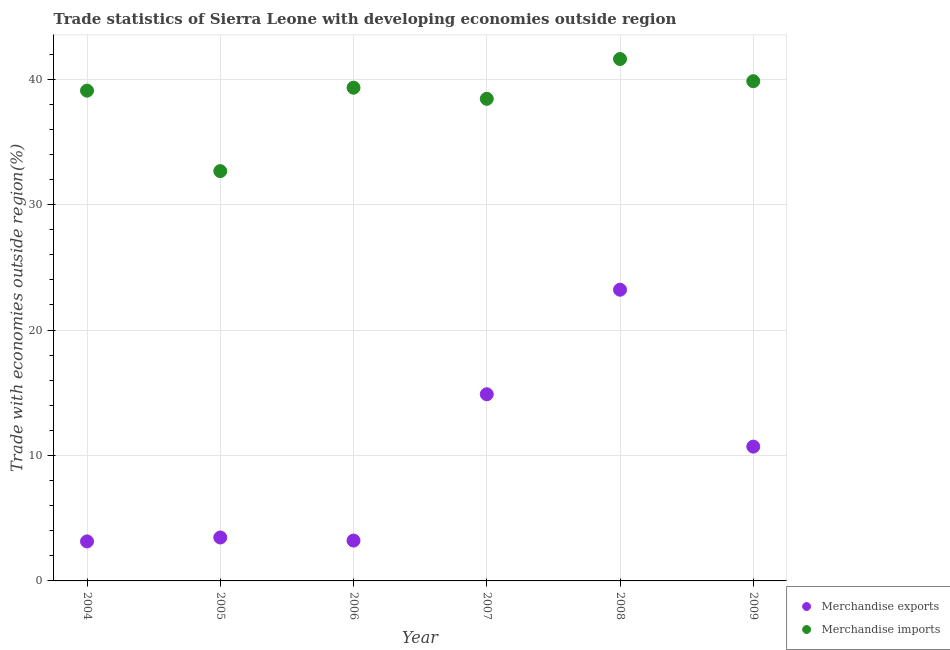Is the number of dotlines equal to the number of legend labels?
Your answer should be very brief. Yes. What is the merchandise imports in 2005?
Provide a short and direct response. 32.67. Across all years, what is the maximum merchandise exports?
Ensure brevity in your answer.  23.22. Across all years, what is the minimum merchandise exports?
Your answer should be very brief. 3.15. In which year was the merchandise exports maximum?
Offer a very short reply. 2008. In which year was the merchandise imports minimum?
Offer a very short reply. 2005. What is the total merchandise imports in the graph?
Your answer should be very brief. 230.96. What is the difference between the merchandise exports in 2005 and that in 2006?
Keep it short and to the point. 0.24. What is the difference between the merchandise imports in 2008 and the merchandise exports in 2009?
Offer a terse response. 30.9. What is the average merchandise exports per year?
Give a very brief answer. 9.77. In the year 2009, what is the difference between the merchandise imports and merchandise exports?
Keep it short and to the point. 29.13. What is the ratio of the merchandise exports in 2005 to that in 2009?
Provide a succinct answer. 0.32. Is the merchandise imports in 2008 less than that in 2009?
Keep it short and to the point. No. Is the difference between the merchandise exports in 2004 and 2005 greater than the difference between the merchandise imports in 2004 and 2005?
Your answer should be very brief. No. What is the difference between the highest and the second highest merchandise exports?
Provide a short and direct response. 8.33. What is the difference between the highest and the lowest merchandise exports?
Ensure brevity in your answer.  20.06. Is the merchandise imports strictly less than the merchandise exports over the years?
Give a very brief answer. No. How many dotlines are there?
Give a very brief answer. 2. Are the values on the major ticks of Y-axis written in scientific E-notation?
Your answer should be very brief. No. Does the graph contain any zero values?
Keep it short and to the point. No. Does the graph contain grids?
Provide a succinct answer. Yes. How many legend labels are there?
Keep it short and to the point. 2. What is the title of the graph?
Ensure brevity in your answer.  Trade statistics of Sierra Leone with developing economies outside region. Does "GDP per capita" appear as one of the legend labels in the graph?
Your response must be concise. No. What is the label or title of the Y-axis?
Ensure brevity in your answer.  Trade with economies outside region(%). What is the Trade with economies outside region(%) in Merchandise exports in 2004?
Make the answer very short. 3.15. What is the Trade with economies outside region(%) in Merchandise imports in 2004?
Offer a very short reply. 39.09. What is the Trade with economies outside region(%) in Merchandise exports in 2005?
Ensure brevity in your answer.  3.46. What is the Trade with economies outside region(%) in Merchandise imports in 2005?
Offer a very short reply. 32.67. What is the Trade with economies outside region(%) in Merchandise exports in 2006?
Give a very brief answer. 3.22. What is the Trade with economies outside region(%) in Merchandise imports in 2006?
Your answer should be very brief. 39.32. What is the Trade with economies outside region(%) of Merchandise exports in 2007?
Offer a very short reply. 14.88. What is the Trade with economies outside region(%) in Merchandise imports in 2007?
Offer a very short reply. 38.44. What is the Trade with economies outside region(%) of Merchandise exports in 2008?
Your answer should be very brief. 23.22. What is the Trade with economies outside region(%) in Merchandise imports in 2008?
Your answer should be very brief. 41.61. What is the Trade with economies outside region(%) of Merchandise exports in 2009?
Keep it short and to the point. 10.71. What is the Trade with economies outside region(%) of Merchandise imports in 2009?
Make the answer very short. 39.84. Across all years, what is the maximum Trade with economies outside region(%) in Merchandise exports?
Offer a terse response. 23.22. Across all years, what is the maximum Trade with economies outside region(%) in Merchandise imports?
Your answer should be very brief. 41.61. Across all years, what is the minimum Trade with economies outside region(%) of Merchandise exports?
Your answer should be very brief. 3.15. Across all years, what is the minimum Trade with economies outside region(%) in Merchandise imports?
Your answer should be very brief. 32.67. What is the total Trade with economies outside region(%) in Merchandise exports in the graph?
Give a very brief answer. 58.63. What is the total Trade with economies outside region(%) of Merchandise imports in the graph?
Ensure brevity in your answer.  230.96. What is the difference between the Trade with economies outside region(%) of Merchandise exports in 2004 and that in 2005?
Provide a succinct answer. -0.31. What is the difference between the Trade with economies outside region(%) in Merchandise imports in 2004 and that in 2005?
Offer a terse response. 6.42. What is the difference between the Trade with economies outside region(%) in Merchandise exports in 2004 and that in 2006?
Offer a terse response. -0.07. What is the difference between the Trade with economies outside region(%) in Merchandise imports in 2004 and that in 2006?
Give a very brief answer. -0.23. What is the difference between the Trade with economies outside region(%) in Merchandise exports in 2004 and that in 2007?
Your answer should be compact. -11.73. What is the difference between the Trade with economies outside region(%) in Merchandise imports in 2004 and that in 2007?
Give a very brief answer. 0.65. What is the difference between the Trade with economies outside region(%) in Merchandise exports in 2004 and that in 2008?
Make the answer very short. -20.06. What is the difference between the Trade with economies outside region(%) of Merchandise imports in 2004 and that in 2008?
Offer a terse response. -2.52. What is the difference between the Trade with economies outside region(%) of Merchandise exports in 2004 and that in 2009?
Make the answer very short. -7.56. What is the difference between the Trade with economies outside region(%) in Merchandise imports in 2004 and that in 2009?
Provide a short and direct response. -0.75. What is the difference between the Trade with economies outside region(%) in Merchandise exports in 2005 and that in 2006?
Ensure brevity in your answer.  0.24. What is the difference between the Trade with economies outside region(%) of Merchandise imports in 2005 and that in 2006?
Your answer should be compact. -6.65. What is the difference between the Trade with economies outside region(%) of Merchandise exports in 2005 and that in 2007?
Offer a terse response. -11.42. What is the difference between the Trade with economies outside region(%) in Merchandise imports in 2005 and that in 2007?
Provide a succinct answer. -5.77. What is the difference between the Trade with economies outside region(%) in Merchandise exports in 2005 and that in 2008?
Make the answer very short. -19.75. What is the difference between the Trade with economies outside region(%) of Merchandise imports in 2005 and that in 2008?
Offer a terse response. -8.94. What is the difference between the Trade with economies outside region(%) in Merchandise exports in 2005 and that in 2009?
Your answer should be very brief. -7.25. What is the difference between the Trade with economies outside region(%) in Merchandise imports in 2005 and that in 2009?
Give a very brief answer. -7.17. What is the difference between the Trade with economies outside region(%) of Merchandise exports in 2006 and that in 2007?
Your answer should be compact. -11.66. What is the difference between the Trade with economies outside region(%) in Merchandise imports in 2006 and that in 2007?
Give a very brief answer. 0.88. What is the difference between the Trade with economies outside region(%) in Merchandise exports in 2006 and that in 2008?
Provide a succinct answer. -20. What is the difference between the Trade with economies outside region(%) of Merchandise imports in 2006 and that in 2008?
Your response must be concise. -2.29. What is the difference between the Trade with economies outside region(%) in Merchandise exports in 2006 and that in 2009?
Your answer should be compact. -7.49. What is the difference between the Trade with economies outside region(%) of Merchandise imports in 2006 and that in 2009?
Offer a very short reply. -0.52. What is the difference between the Trade with economies outside region(%) of Merchandise exports in 2007 and that in 2008?
Keep it short and to the point. -8.33. What is the difference between the Trade with economies outside region(%) of Merchandise imports in 2007 and that in 2008?
Make the answer very short. -3.17. What is the difference between the Trade with economies outside region(%) in Merchandise exports in 2007 and that in 2009?
Your answer should be compact. 4.17. What is the difference between the Trade with economies outside region(%) of Merchandise imports in 2007 and that in 2009?
Your answer should be compact. -1.4. What is the difference between the Trade with economies outside region(%) of Merchandise exports in 2008 and that in 2009?
Offer a very short reply. 12.51. What is the difference between the Trade with economies outside region(%) in Merchandise imports in 2008 and that in 2009?
Give a very brief answer. 1.77. What is the difference between the Trade with economies outside region(%) of Merchandise exports in 2004 and the Trade with economies outside region(%) of Merchandise imports in 2005?
Ensure brevity in your answer.  -29.52. What is the difference between the Trade with economies outside region(%) of Merchandise exports in 2004 and the Trade with economies outside region(%) of Merchandise imports in 2006?
Make the answer very short. -36.17. What is the difference between the Trade with economies outside region(%) of Merchandise exports in 2004 and the Trade with economies outside region(%) of Merchandise imports in 2007?
Your response must be concise. -35.28. What is the difference between the Trade with economies outside region(%) of Merchandise exports in 2004 and the Trade with economies outside region(%) of Merchandise imports in 2008?
Your answer should be very brief. -38.46. What is the difference between the Trade with economies outside region(%) of Merchandise exports in 2004 and the Trade with economies outside region(%) of Merchandise imports in 2009?
Your answer should be compact. -36.69. What is the difference between the Trade with economies outside region(%) in Merchandise exports in 2005 and the Trade with economies outside region(%) in Merchandise imports in 2006?
Provide a succinct answer. -35.86. What is the difference between the Trade with economies outside region(%) of Merchandise exports in 2005 and the Trade with economies outside region(%) of Merchandise imports in 2007?
Keep it short and to the point. -34.97. What is the difference between the Trade with economies outside region(%) of Merchandise exports in 2005 and the Trade with economies outside region(%) of Merchandise imports in 2008?
Ensure brevity in your answer.  -38.15. What is the difference between the Trade with economies outside region(%) in Merchandise exports in 2005 and the Trade with economies outside region(%) in Merchandise imports in 2009?
Your response must be concise. -36.38. What is the difference between the Trade with economies outside region(%) of Merchandise exports in 2006 and the Trade with economies outside region(%) of Merchandise imports in 2007?
Your answer should be compact. -35.22. What is the difference between the Trade with economies outside region(%) in Merchandise exports in 2006 and the Trade with economies outside region(%) in Merchandise imports in 2008?
Offer a very short reply. -38.39. What is the difference between the Trade with economies outside region(%) of Merchandise exports in 2006 and the Trade with economies outside region(%) of Merchandise imports in 2009?
Your answer should be compact. -36.62. What is the difference between the Trade with economies outside region(%) of Merchandise exports in 2007 and the Trade with economies outside region(%) of Merchandise imports in 2008?
Ensure brevity in your answer.  -26.73. What is the difference between the Trade with economies outside region(%) of Merchandise exports in 2007 and the Trade with economies outside region(%) of Merchandise imports in 2009?
Provide a short and direct response. -24.96. What is the difference between the Trade with economies outside region(%) in Merchandise exports in 2008 and the Trade with economies outside region(%) in Merchandise imports in 2009?
Offer a terse response. -16.62. What is the average Trade with economies outside region(%) in Merchandise exports per year?
Make the answer very short. 9.77. What is the average Trade with economies outside region(%) in Merchandise imports per year?
Offer a very short reply. 38.49. In the year 2004, what is the difference between the Trade with economies outside region(%) of Merchandise exports and Trade with economies outside region(%) of Merchandise imports?
Your answer should be compact. -35.94. In the year 2005, what is the difference between the Trade with economies outside region(%) in Merchandise exports and Trade with economies outside region(%) in Merchandise imports?
Your response must be concise. -29.21. In the year 2006, what is the difference between the Trade with economies outside region(%) in Merchandise exports and Trade with economies outside region(%) in Merchandise imports?
Provide a short and direct response. -36.1. In the year 2007, what is the difference between the Trade with economies outside region(%) of Merchandise exports and Trade with economies outside region(%) of Merchandise imports?
Make the answer very short. -23.55. In the year 2008, what is the difference between the Trade with economies outside region(%) of Merchandise exports and Trade with economies outside region(%) of Merchandise imports?
Give a very brief answer. -18.39. In the year 2009, what is the difference between the Trade with economies outside region(%) of Merchandise exports and Trade with economies outside region(%) of Merchandise imports?
Give a very brief answer. -29.13. What is the ratio of the Trade with economies outside region(%) in Merchandise exports in 2004 to that in 2005?
Your answer should be compact. 0.91. What is the ratio of the Trade with economies outside region(%) in Merchandise imports in 2004 to that in 2005?
Make the answer very short. 1.2. What is the ratio of the Trade with economies outside region(%) in Merchandise exports in 2004 to that in 2006?
Give a very brief answer. 0.98. What is the ratio of the Trade with economies outside region(%) of Merchandise exports in 2004 to that in 2007?
Keep it short and to the point. 0.21. What is the ratio of the Trade with economies outside region(%) of Merchandise imports in 2004 to that in 2007?
Your answer should be compact. 1.02. What is the ratio of the Trade with economies outside region(%) in Merchandise exports in 2004 to that in 2008?
Ensure brevity in your answer.  0.14. What is the ratio of the Trade with economies outside region(%) of Merchandise imports in 2004 to that in 2008?
Make the answer very short. 0.94. What is the ratio of the Trade with economies outside region(%) in Merchandise exports in 2004 to that in 2009?
Provide a short and direct response. 0.29. What is the ratio of the Trade with economies outside region(%) of Merchandise imports in 2004 to that in 2009?
Offer a very short reply. 0.98. What is the ratio of the Trade with economies outside region(%) of Merchandise exports in 2005 to that in 2006?
Your answer should be compact. 1.08. What is the ratio of the Trade with economies outside region(%) of Merchandise imports in 2005 to that in 2006?
Your answer should be very brief. 0.83. What is the ratio of the Trade with economies outside region(%) of Merchandise exports in 2005 to that in 2007?
Your answer should be compact. 0.23. What is the ratio of the Trade with economies outside region(%) of Merchandise imports in 2005 to that in 2007?
Offer a terse response. 0.85. What is the ratio of the Trade with economies outside region(%) in Merchandise exports in 2005 to that in 2008?
Keep it short and to the point. 0.15. What is the ratio of the Trade with economies outside region(%) of Merchandise imports in 2005 to that in 2008?
Your answer should be very brief. 0.79. What is the ratio of the Trade with economies outside region(%) in Merchandise exports in 2005 to that in 2009?
Provide a short and direct response. 0.32. What is the ratio of the Trade with economies outside region(%) of Merchandise imports in 2005 to that in 2009?
Your response must be concise. 0.82. What is the ratio of the Trade with economies outside region(%) of Merchandise exports in 2006 to that in 2007?
Provide a short and direct response. 0.22. What is the ratio of the Trade with economies outside region(%) of Merchandise imports in 2006 to that in 2007?
Your response must be concise. 1.02. What is the ratio of the Trade with economies outside region(%) in Merchandise exports in 2006 to that in 2008?
Your answer should be compact. 0.14. What is the ratio of the Trade with economies outside region(%) of Merchandise imports in 2006 to that in 2008?
Keep it short and to the point. 0.94. What is the ratio of the Trade with economies outside region(%) of Merchandise exports in 2006 to that in 2009?
Offer a terse response. 0.3. What is the ratio of the Trade with economies outside region(%) in Merchandise imports in 2006 to that in 2009?
Ensure brevity in your answer.  0.99. What is the ratio of the Trade with economies outside region(%) of Merchandise exports in 2007 to that in 2008?
Give a very brief answer. 0.64. What is the ratio of the Trade with economies outside region(%) of Merchandise imports in 2007 to that in 2008?
Provide a succinct answer. 0.92. What is the ratio of the Trade with economies outside region(%) of Merchandise exports in 2007 to that in 2009?
Your response must be concise. 1.39. What is the ratio of the Trade with economies outside region(%) of Merchandise imports in 2007 to that in 2009?
Make the answer very short. 0.96. What is the ratio of the Trade with economies outside region(%) of Merchandise exports in 2008 to that in 2009?
Your answer should be compact. 2.17. What is the ratio of the Trade with economies outside region(%) of Merchandise imports in 2008 to that in 2009?
Provide a short and direct response. 1.04. What is the difference between the highest and the second highest Trade with economies outside region(%) in Merchandise exports?
Your answer should be compact. 8.33. What is the difference between the highest and the second highest Trade with economies outside region(%) in Merchandise imports?
Make the answer very short. 1.77. What is the difference between the highest and the lowest Trade with economies outside region(%) of Merchandise exports?
Your answer should be very brief. 20.06. What is the difference between the highest and the lowest Trade with economies outside region(%) of Merchandise imports?
Give a very brief answer. 8.94. 